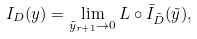Convert formula to latex. <formula><loc_0><loc_0><loc_500><loc_500>I _ { D } ( y ) = \lim _ { \tilde { y } _ { r + 1 } \rightarrow 0 } L \circ \bar { I } _ { \tilde { D } } ( \tilde { y } ) ,</formula> 